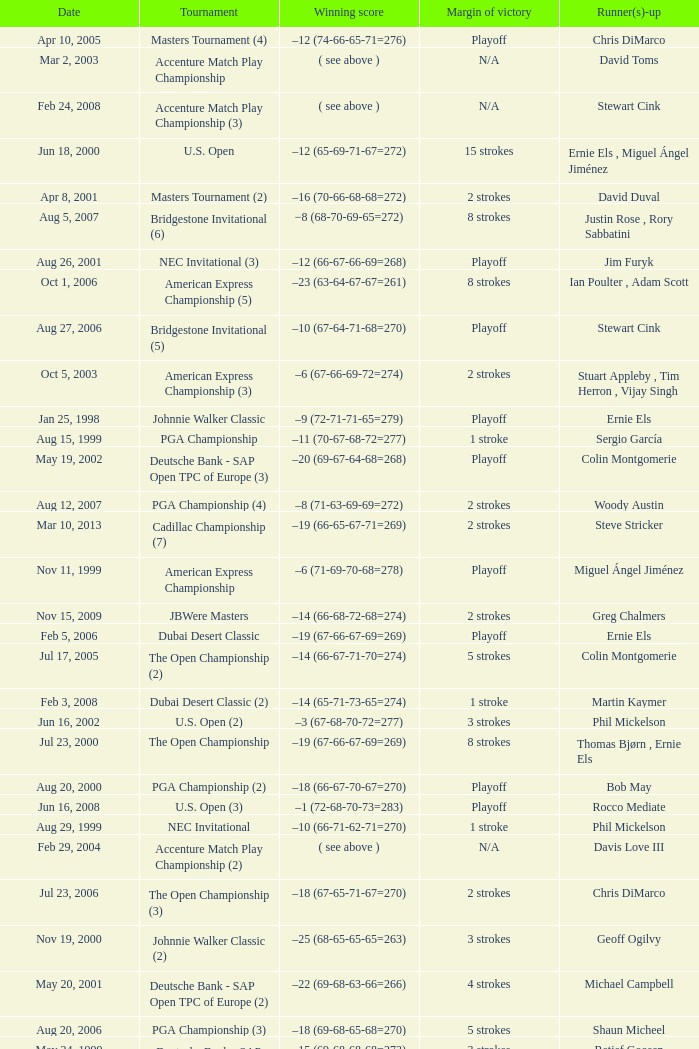Who is Runner(s)-up that has a Date of may 24, 1999? Retief Goosen. 